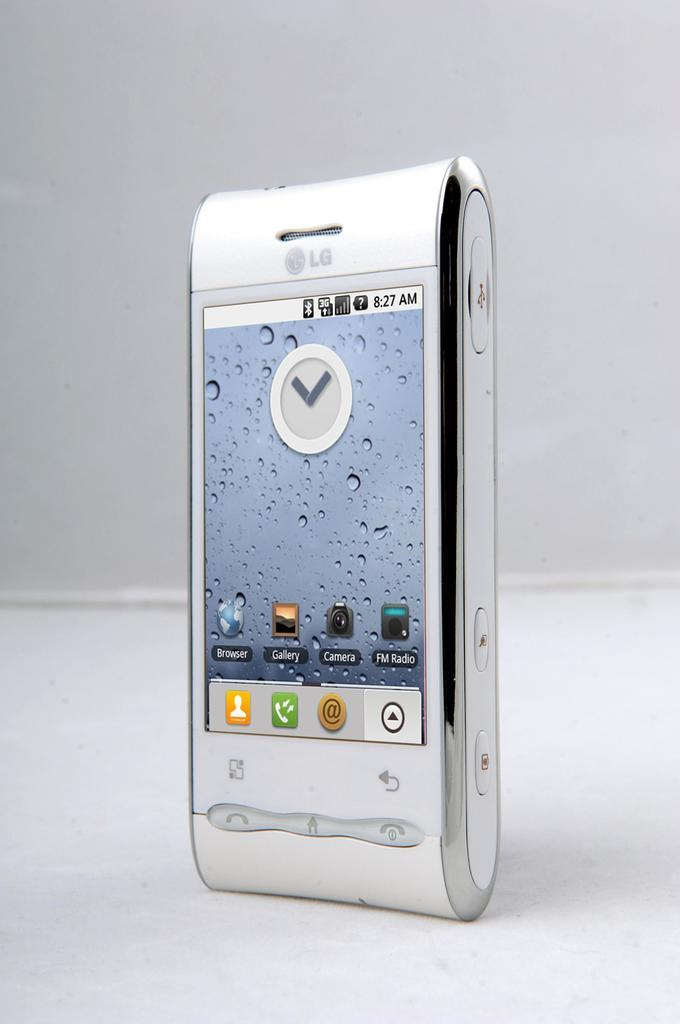What object is the main focus of the image? There is a mobile in the image. Where is the mobile located? The mobile is on a surface. What can be seen in the background of the image? There is a wall in the background of the image. How much wealth is represented by the beans in the image? There are no beans present in the image, so it is not possible to determine the amount of wealth they might represent. 